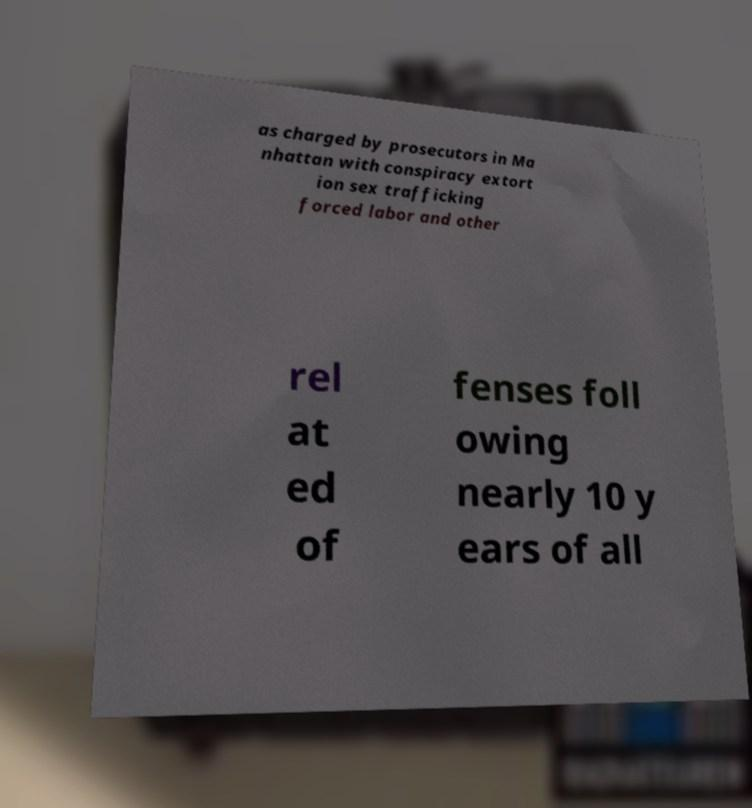Please identify and transcribe the text found in this image. as charged by prosecutors in Ma nhattan with conspiracy extort ion sex trafficking forced labor and other rel at ed of fenses foll owing nearly 10 y ears of all 